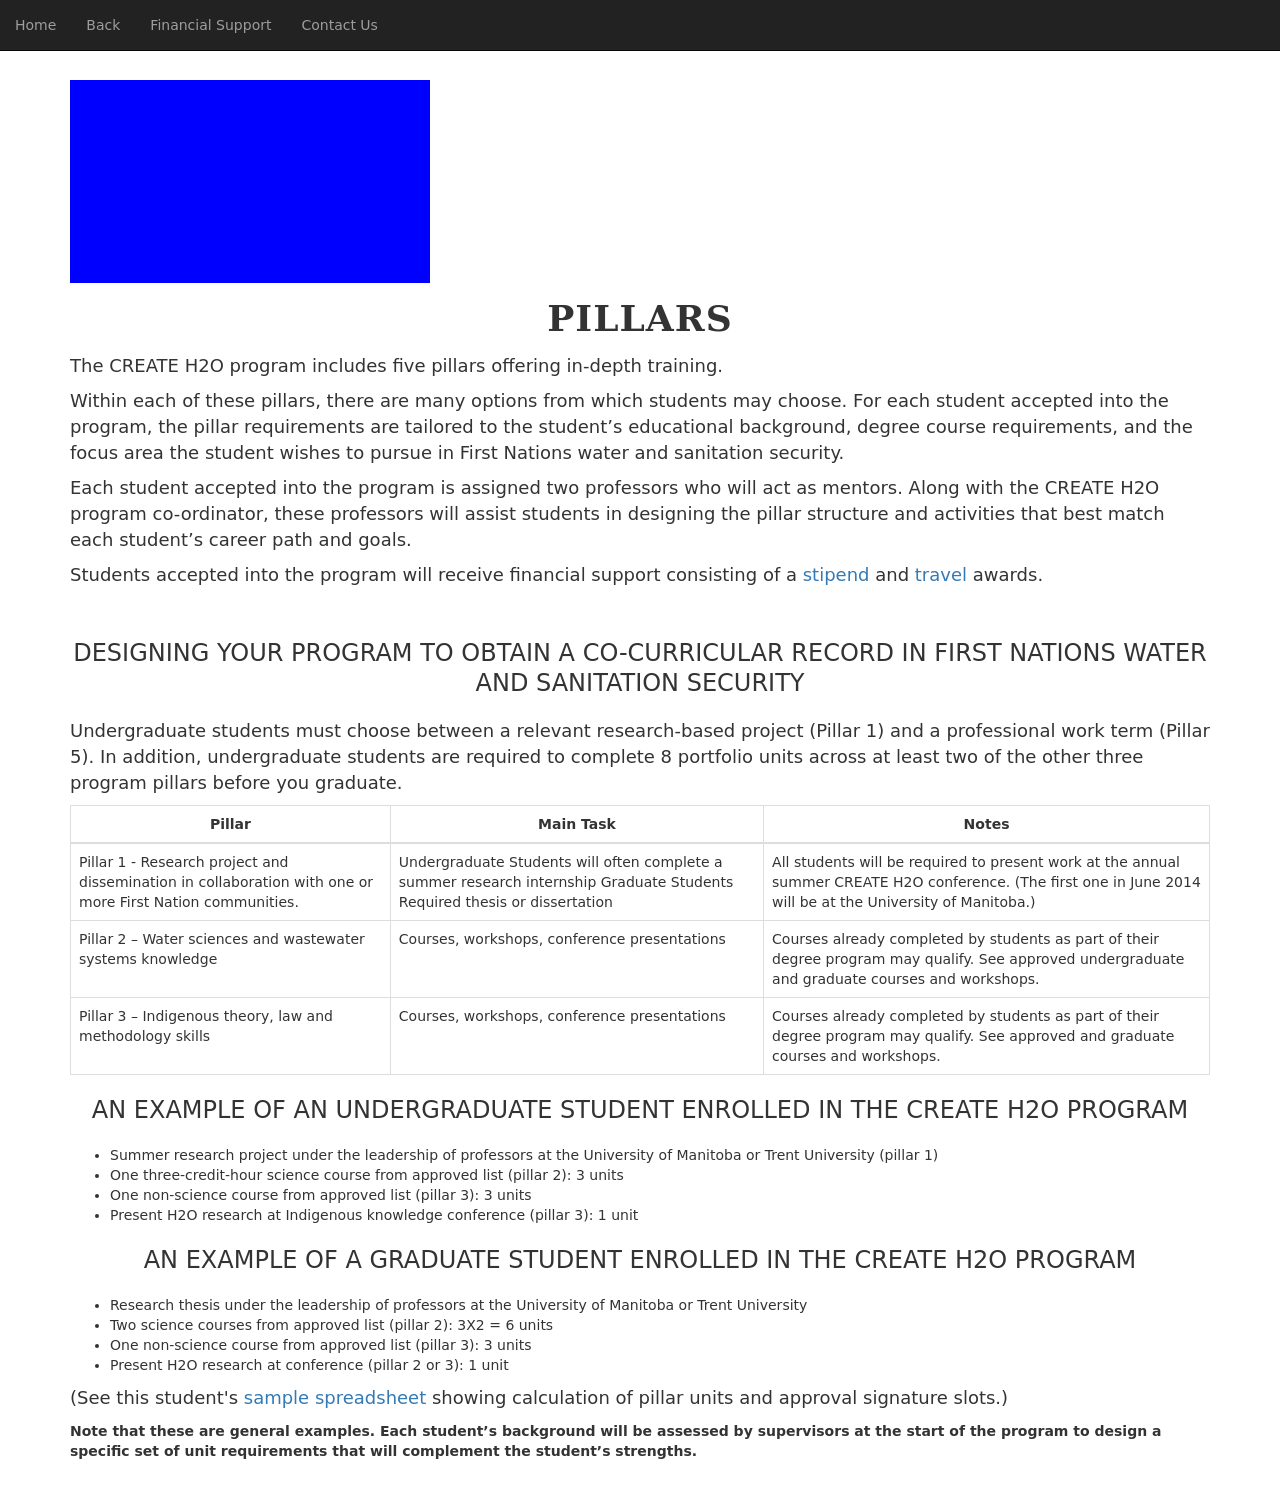Could you detail the process for assembling this website using HTML? Certainly! To assemble a website like the one described, you'd start with a basic HTML5 structure. Begin with the <!DOCTYPE html> declaration to specify the HTML version. The <html> tag encloses all your HTML content. Within this, separate sections into <head> and <body>. 

In the <head>, include meta tags for responsive design and character set with <meta charset="utf-8"> and <meta name='viewport' content='width=device-width, initial-scale=1'>. Define the site's appearance with a <style> section, including CSS rules for layout, typography, and responsive design features. 

The <body> contains the visible page content. This typically involves navigational elements like a navbar, main content sections marked by headings, paragraphs, and perhaps interactive or informational tables and lists. Conclude with any necessary scripts for dynamic content or functionality at the end of the body. 